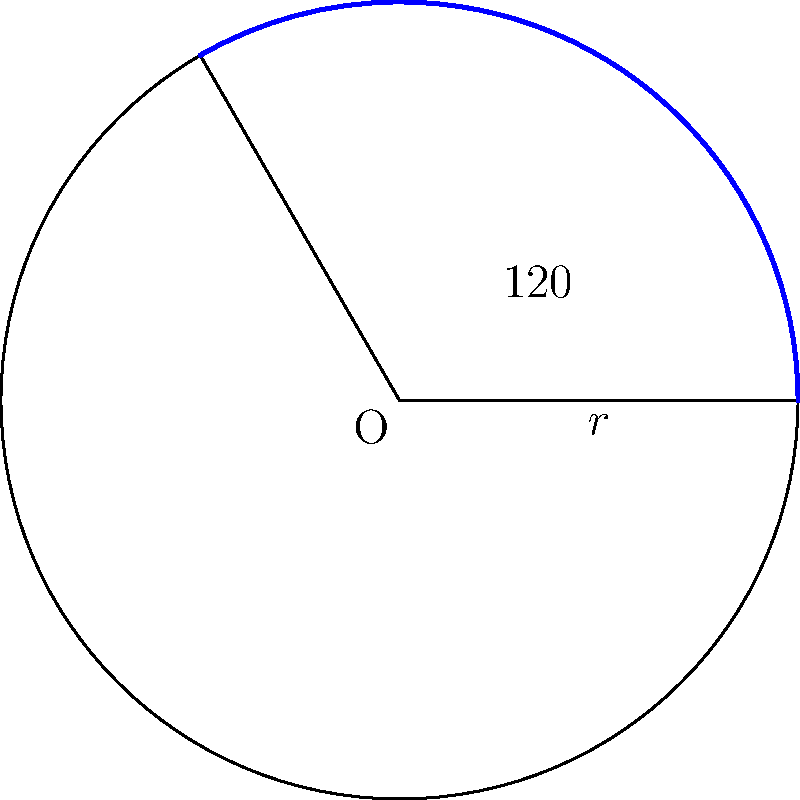In un grafico che rappresenta il rendimento di un portafoglio diversificato, un settore circolare mostra la performance di un particolare asset. Se l'angolo al centro di questo settore è di 120° e il raggio del cerchio è di 5 cm, qual è l'area del settore in cm²? (Usa π = 3,14) Per calcolare l'area di un settore circolare, seguiamo questi passaggi:

1) La formula per l'area di un settore circolare è:

   $$A = \frac{\theta}{360°} \cdot \pi r^2$$

   dove $A$ è l'area, $\theta$ è l'angolo al centro in gradi, e $r$ è il raggio.

2) Sostituiamo i valori dati:
   $\theta = 120°$
   $r = 5$ cm
   $\pi = 3,14$

3) Inseriamo questi valori nella formula:

   $$A = \frac{120°}{360°} \cdot 3,14 \cdot 5^2$$

4) Semplifichiamo:
   
   $$A = \frac{1}{3} \cdot 3,14 \cdot 25$$

5) Calcoliamo:

   $$A = \frac{1}{3} \cdot 78,5 = 26,17$$

Quindi, l'area del settore circolare è approssimativamente 26,17 cm².
Answer: 26,17 cm² 